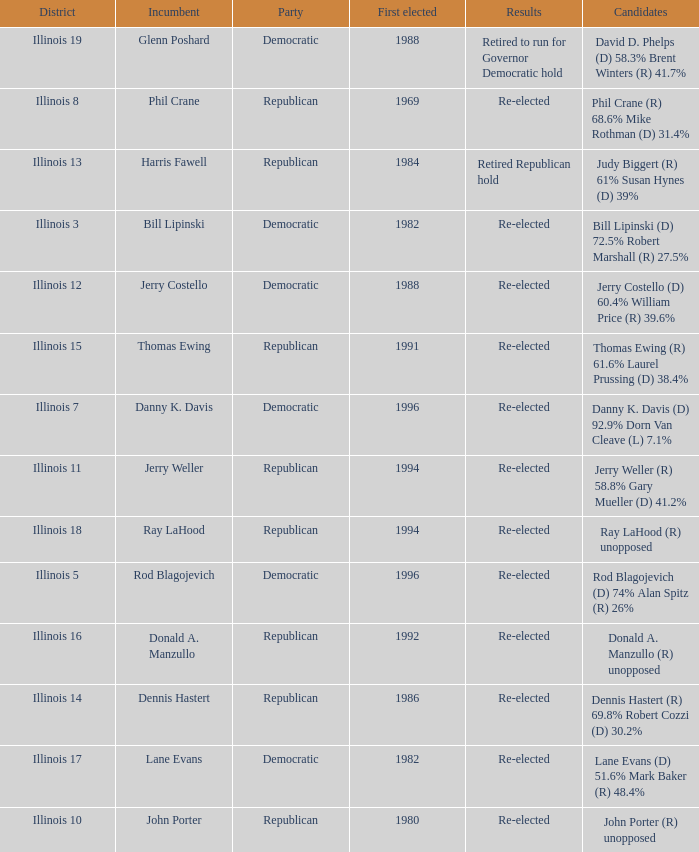What was the result in Illinois 7? Re-elected. 